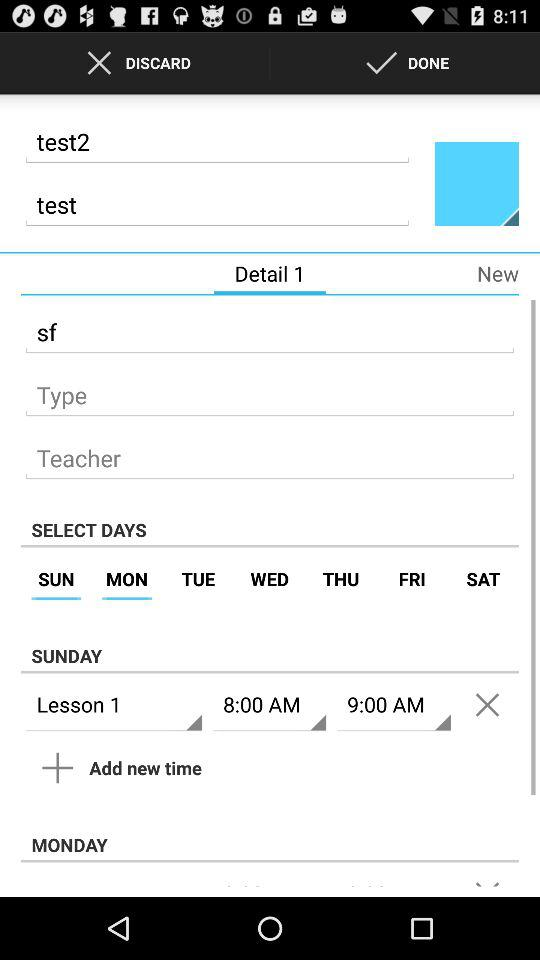What's the test timing for Lesson 1? The test timing for Lesson 1 is from 8 a.m. to 9 a.m. 